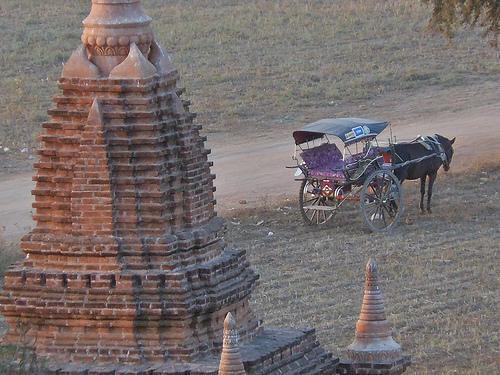How many carriages are there?
Give a very brief answer. 1. How many wheels does the carriage have?
Give a very brief answer. 2. 